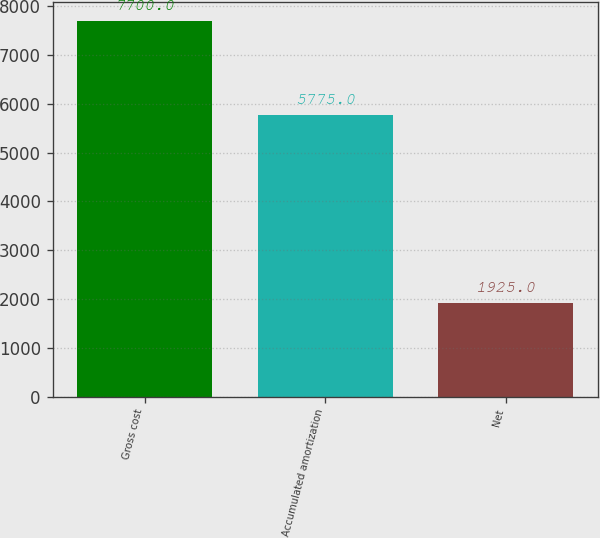Convert chart to OTSL. <chart><loc_0><loc_0><loc_500><loc_500><bar_chart><fcel>Gross cost<fcel>Accumulated amortization<fcel>Net<nl><fcel>7700<fcel>5775<fcel>1925<nl></chart> 